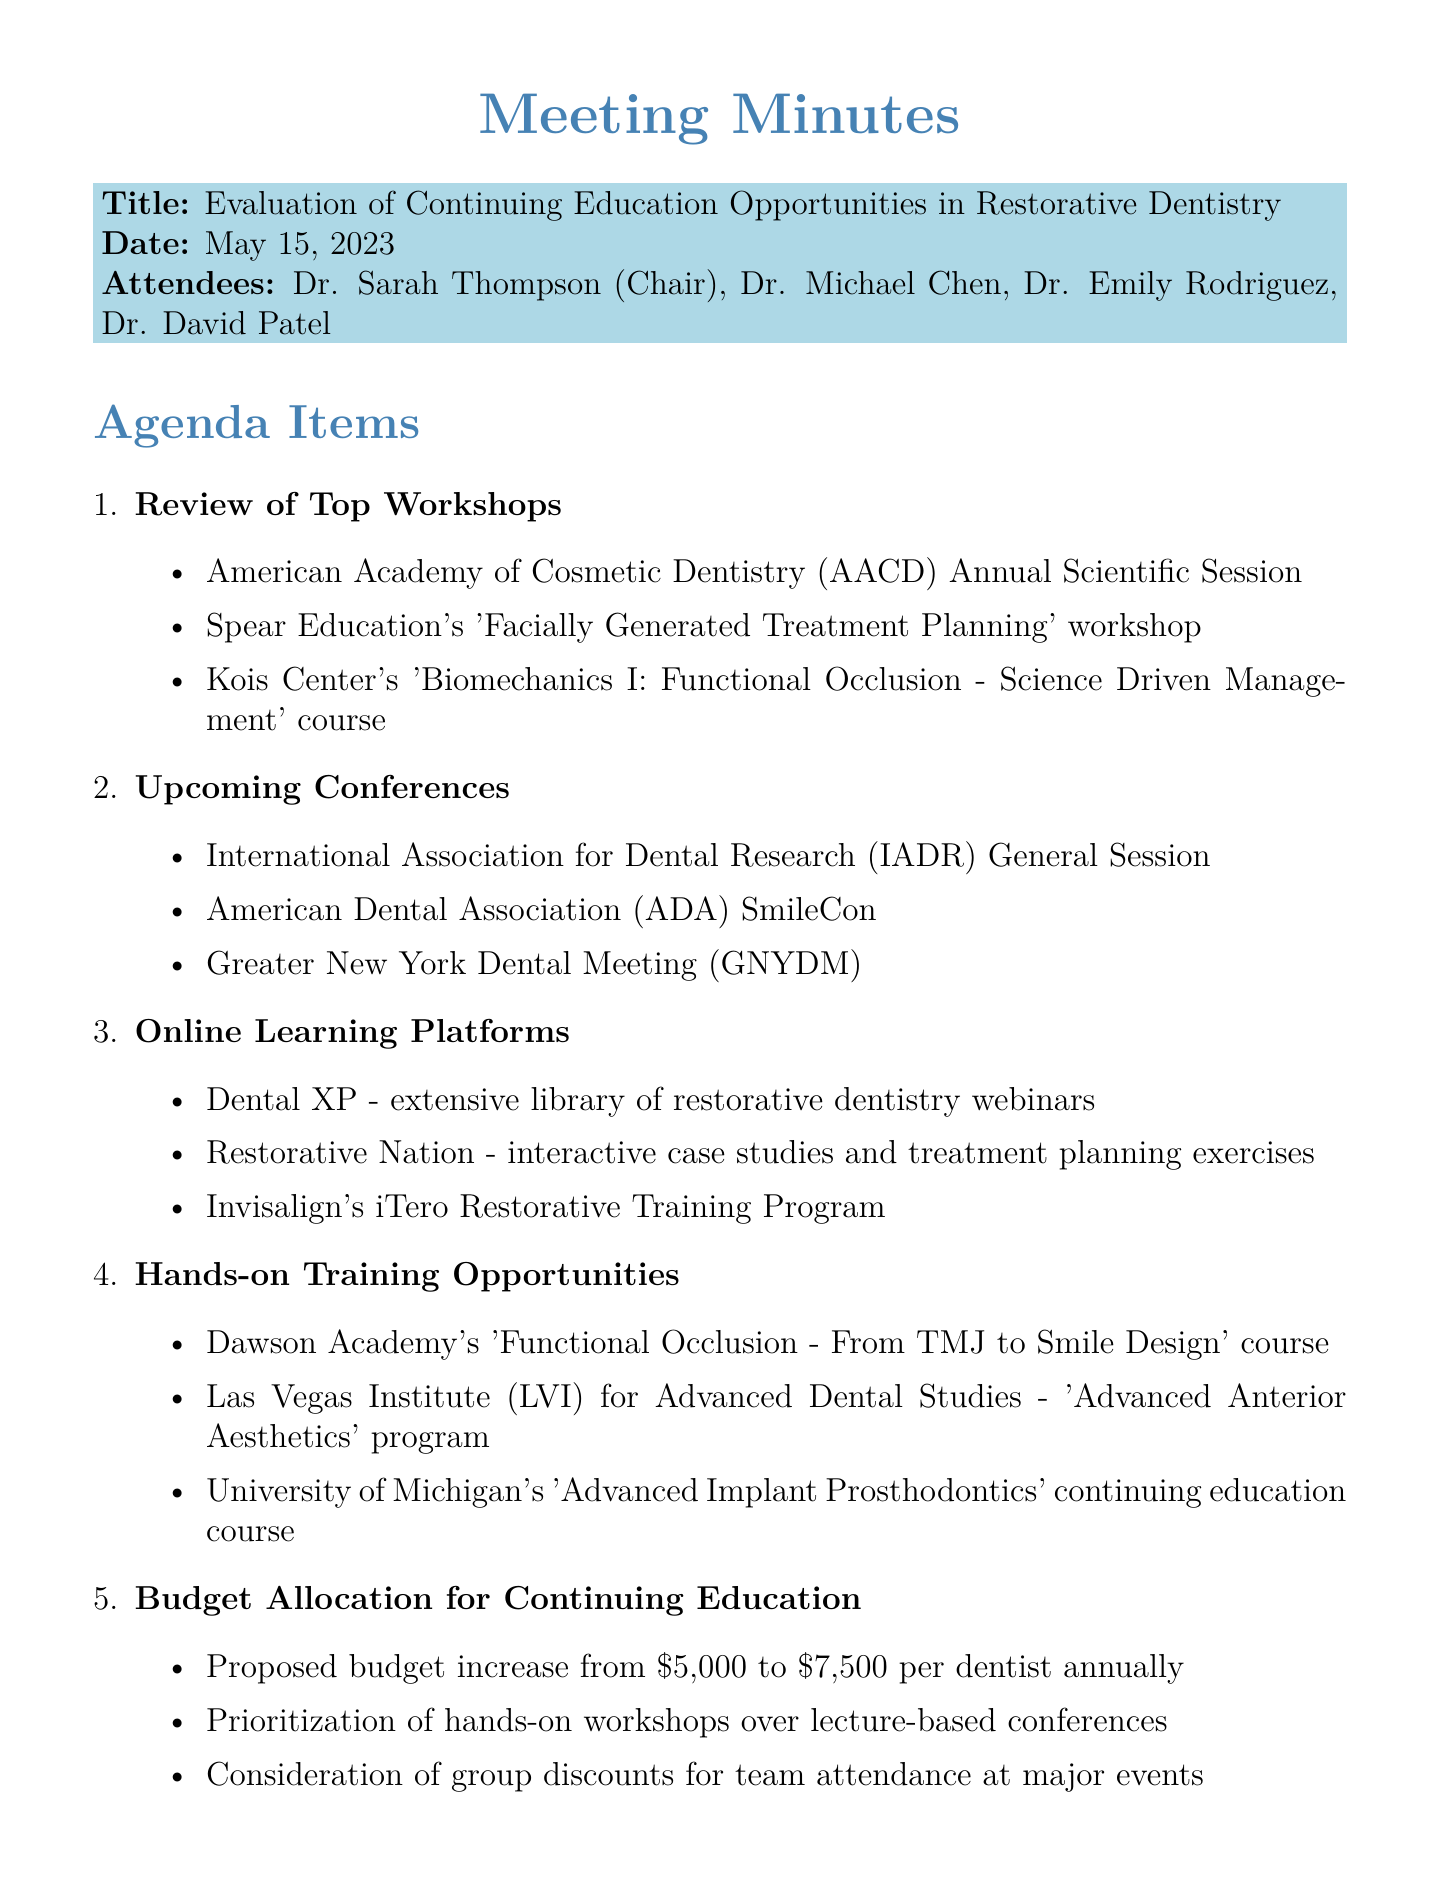what is the date of the meeting? The date of the meeting is mentioned at the start of the document.
Answer: May 15, 2023 who chaired the meeting? The chairperson of the meeting is listed among the attendees.
Answer: Dr. Sarah Thompson what is the proposed budget increase per dentist annually? The proposed budget increase is clearly stated in the budget allocation section.
Answer: $7,500 which workshop focuses on treatment planning? The specific workshop focusing on treatment planning is included in the review of top workshops section.
Answer: Facially Generated Treatment Planning what is the name of the platform that offers interactive case studies? The document lists various online learning platforms, one of which offers interactive case studies.
Answer: Restorative Nation how many attendees were present at the meeting? The number of attendees is listed under the attendees section at the beginning of the document.
Answer: 4 which action item involves researching online learning platforms? The action items section outlines tasks assigned to attendees, one of which specifies researching online learning platforms.
Answer: Dr. Chen what was prioritized over lecture-based conferences? The budget allocation section suggests priorities for continuing education formats.
Answer: Hands-on workshops 